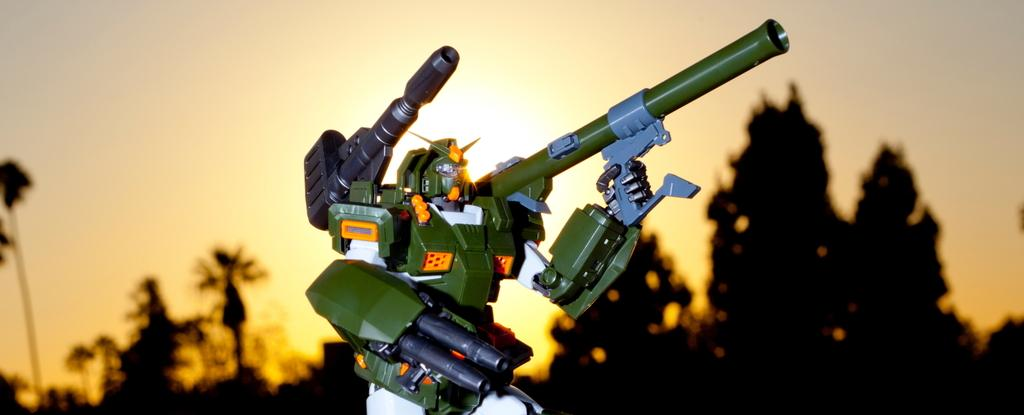What object can be seen in the image? There is a toy in the image. What can be seen in the distance behind the toy? There are trees in the background of the image. What else is visible in the background of the image? The sky is visible in the background of the image. What degree does the toy have in the image? The toy does not have a degree, as degrees are typically associated with academic achievements or qualifications, and the toy is an inanimate object. 